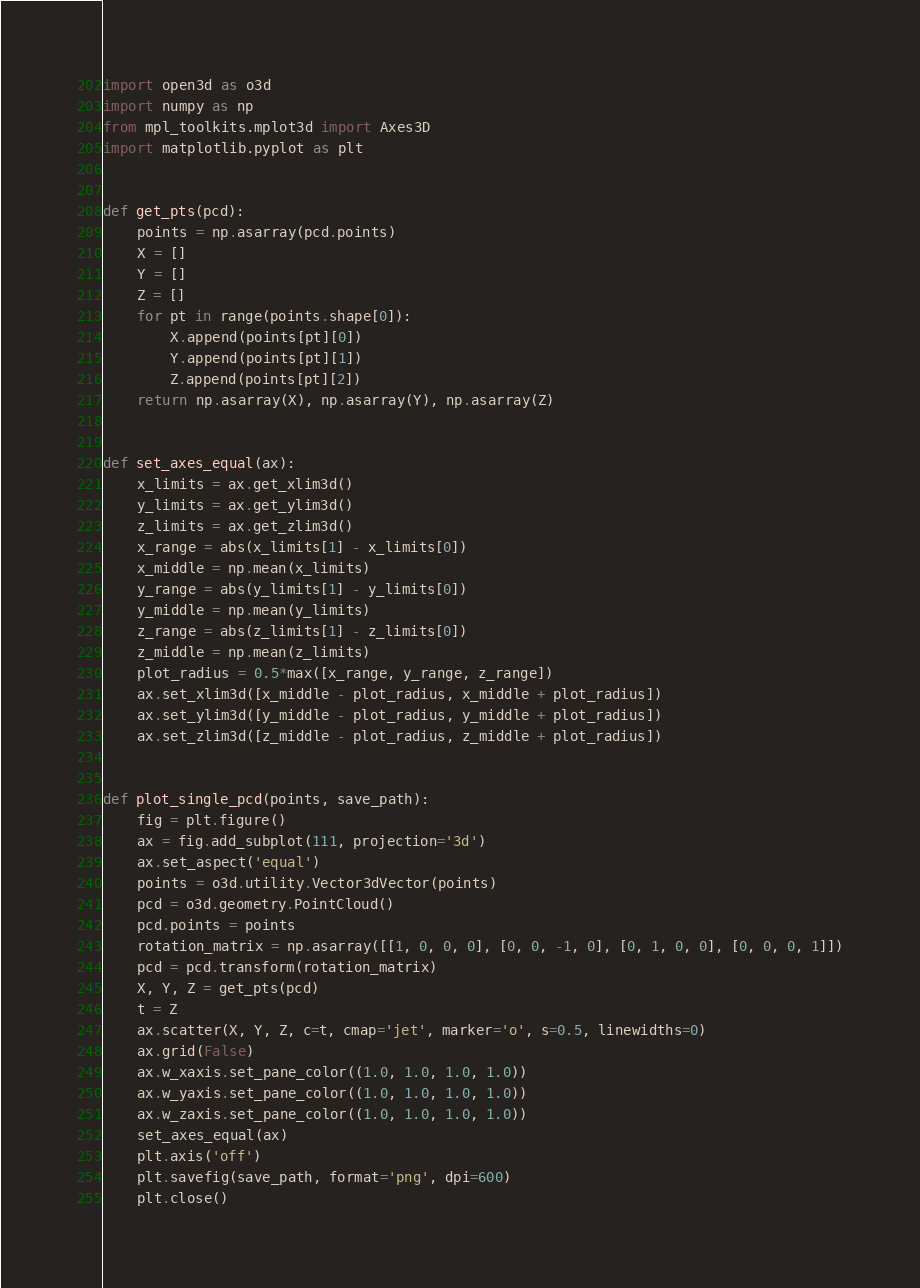Convert code to text. <code><loc_0><loc_0><loc_500><loc_500><_Python_>import open3d as o3d
import numpy as np
from mpl_toolkits.mplot3d import Axes3D
import matplotlib.pyplot as plt


def get_pts(pcd):
    points = np.asarray(pcd.points)
    X = []
    Y = []
    Z = []
    for pt in range(points.shape[0]):
        X.append(points[pt][0])
        Y.append(points[pt][1])
        Z.append(points[pt][2])
    return np.asarray(X), np.asarray(Y), np.asarray(Z)


def set_axes_equal(ax):
    x_limits = ax.get_xlim3d()
    y_limits = ax.get_ylim3d()
    z_limits = ax.get_zlim3d()
    x_range = abs(x_limits[1] - x_limits[0])
    x_middle = np.mean(x_limits)
    y_range = abs(y_limits[1] - y_limits[0])
    y_middle = np.mean(y_limits)
    z_range = abs(z_limits[1] - z_limits[0])
    z_middle = np.mean(z_limits)
    plot_radius = 0.5*max([x_range, y_range, z_range])
    ax.set_xlim3d([x_middle - plot_radius, x_middle + plot_radius])
    ax.set_ylim3d([y_middle - plot_radius, y_middle + plot_radius])
    ax.set_zlim3d([z_middle - plot_radius, z_middle + plot_radius])


def plot_single_pcd(points, save_path):
    fig = plt.figure()
    ax = fig.add_subplot(111, projection='3d')
    ax.set_aspect('equal')
    points = o3d.utility.Vector3dVector(points)
    pcd = o3d.geometry.PointCloud()
    pcd.points = points
    rotation_matrix = np.asarray([[1, 0, 0, 0], [0, 0, -1, 0], [0, 1, 0, 0], [0, 0, 0, 1]])
    pcd = pcd.transform(rotation_matrix)
    X, Y, Z = get_pts(pcd)
    t = Z
    ax.scatter(X, Y, Z, c=t, cmap='jet', marker='o', s=0.5, linewidths=0)
    ax.grid(False)
    ax.w_xaxis.set_pane_color((1.0, 1.0, 1.0, 1.0))
    ax.w_yaxis.set_pane_color((1.0, 1.0, 1.0, 1.0))
    ax.w_zaxis.set_pane_color((1.0, 1.0, 1.0, 1.0))
    set_axes_equal(ax)
    plt.axis('off')
    plt.savefig(save_path, format='png', dpi=600)
    plt.close()








</code> 